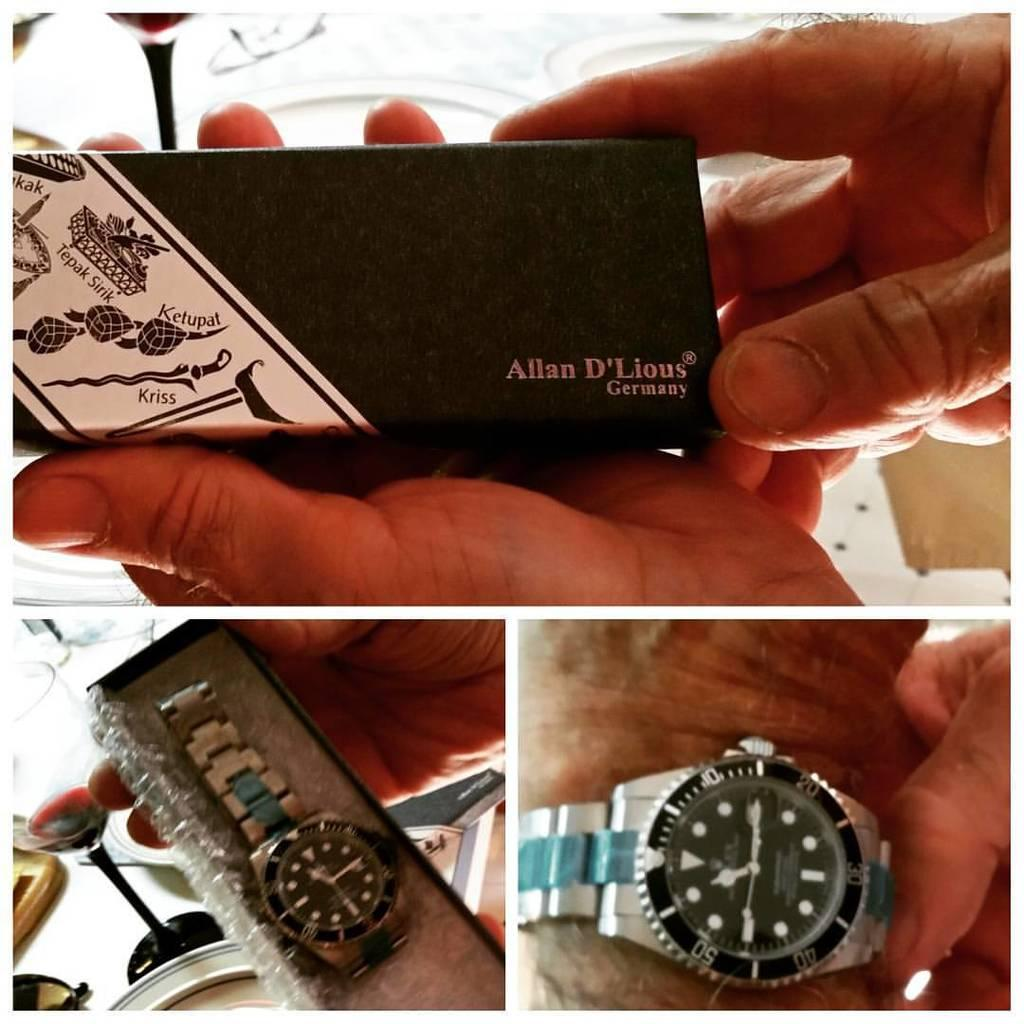<image>
Relay a brief, clear account of the picture shown. A silver Allan D'Lious watch made in Germany. 